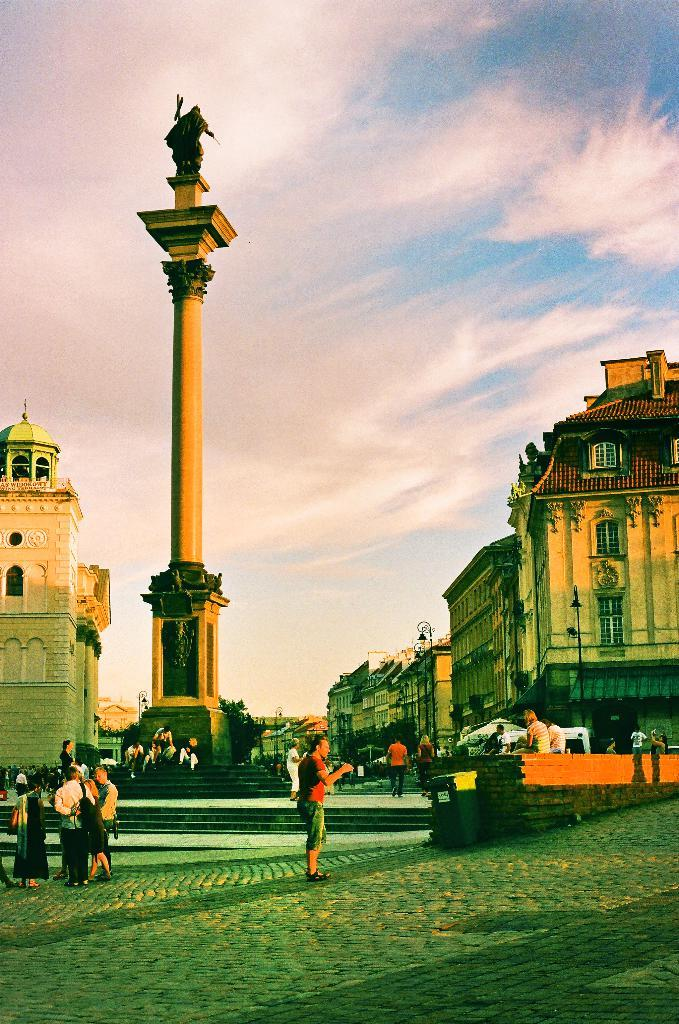How many people are in the group shown in the image? There is a group of persons in the image, but the exact number cannot be determined from the provided facts. What are the people in the group holding? The group of persons is holding an object. What other notable feature can be seen in the image? There is a statue in the image. What can be seen in the background of the image? The sky is visible in the image. What type of badge can be seen on the statue in the image? A: There is no badge present on the statue in the image. How does the paste help the group of persons in the image? There is no mention of paste in the image, so it cannot be determined how it might help the group of persons. 